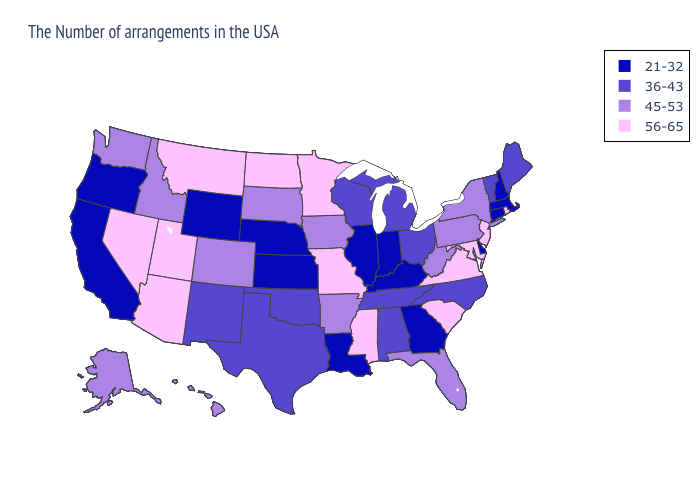Does Vermont have the same value as Wisconsin?
Write a very short answer. Yes. What is the value of New Hampshire?
Keep it brief. 21-32. What is the highest value in states that border Virginia?
Answer briefly. 56-65. What is the lowest value in states that border Massachusetts?
Concise answer only. 21-32. Does North Dakota have the highest value in the MidWest?
Quick response, please. Yes. What is the highest value in the South ?
Quick response, please. 56-65. Which states have the highest value in the USA?
Concise answer only. Rhode Island, New Jersey, Maryland, Virginia, South Carolina, Mississippi, Missouri, Minnesota, North Dakota, Utah, Montana, Arizona, Nevada. Name the states that have a value in the range 36-43?
Quick response, please. Maine, Vermont, North Carolina, Ohio, Michigan, Alabama, Tennessee, Wisconsin, Oklahoma, Texas, New Mexico. What is the value of South Carolina?
Write a very short answer. 56-65. Does Mississippi have the highest value in the South?
Keep it brief. Yes. Does Alaska have the lowest value in the USA?
Be succinct. No. Among the states that border New York , which have the highest value?
Concise answer only. New Jersey. Which states have the lowest value in the MidWest?
Quick response, please. Indiana, Illinois, Kansas, Nebraska. Does the first symbol in the legend represent the smallest category?
Short answer required. Yes. How many symbols are there in the legend?
Keep it brief. 4. 